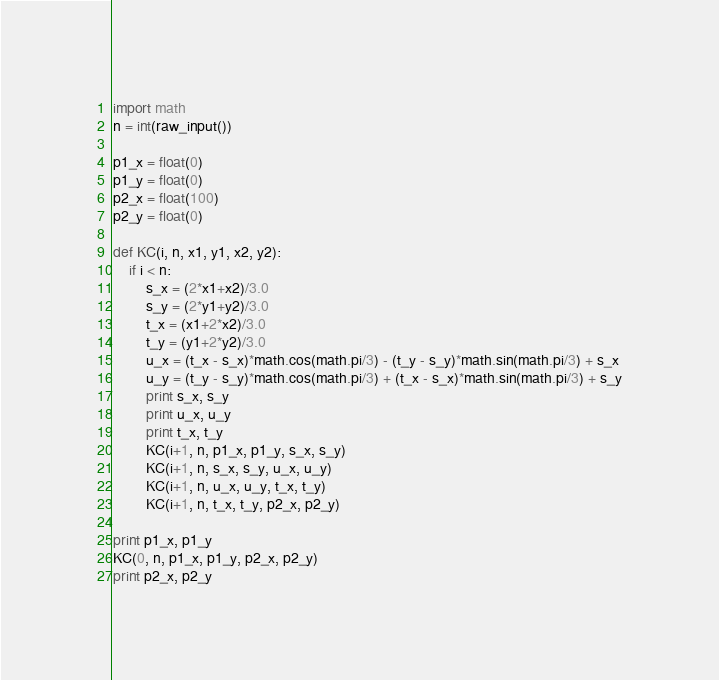<code> <loc_0><loc_0><loc_500><loc_500><_Python_>import math
n = int(raw_input())

p1_x = float(0)
p1_y = float(0)
p2_x = float(100)
p2_y = float(0)

def KC(i, n, x1, y1, x2, y2):
	if i < n:
		s_x = (2*x1+x2)/3.0
		s_y = (2*y1+y2)/3.0
		t_x = (x1+2*x2)/3.0
		t_y = (y1+2*y2)/3.0
		u_x = (t_x - s_x)*math.cos(math.pi/3) - (t_y - s_y)*math.sin(math.pi/3) + s_x
		u_y = (t_y - s_y)*math.cos(math.pi/3) + (t_x - s_x)*math.sin(math.pi/3) + s_y
		print s_x, s_y
		print u_x, u_y
		print t_x, t_y
		KC(i+1, n, p1_x, p1_y, s_x, s_y)
		KC(i+1, n, s_x, s_y, u_x, u_y)
		KC(i+1, n, u_x, u_y, t_x, t_y)
		KC(i+1, n, t_x, t_y, p2_x, p2_y)

print p1_x, p1_y
KC(0, n, p1_x, p1_y, p2_x, p2_y)
print p2_x, p2_y</code> 